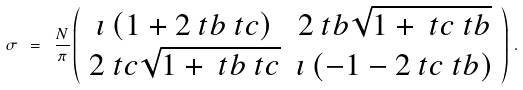<formula> <loc_0><loc_0><loc_500><loc_500>\sigma \ = \ \frac { N } { \pi } \left ( \begin{array} { c c } \imath \left ( { 1 } + 2 \ t b \ t c \right ) & 2 \ t b \sqrt { { 1 } + \ t c \ t b } \\ 2 \ t c \sqrt { { 1 } + \ t b \ t c } & \imath \left ( - { 1 } - 2 \ t c \ t b \right ) \end{array} \right ) \, .</formula> 